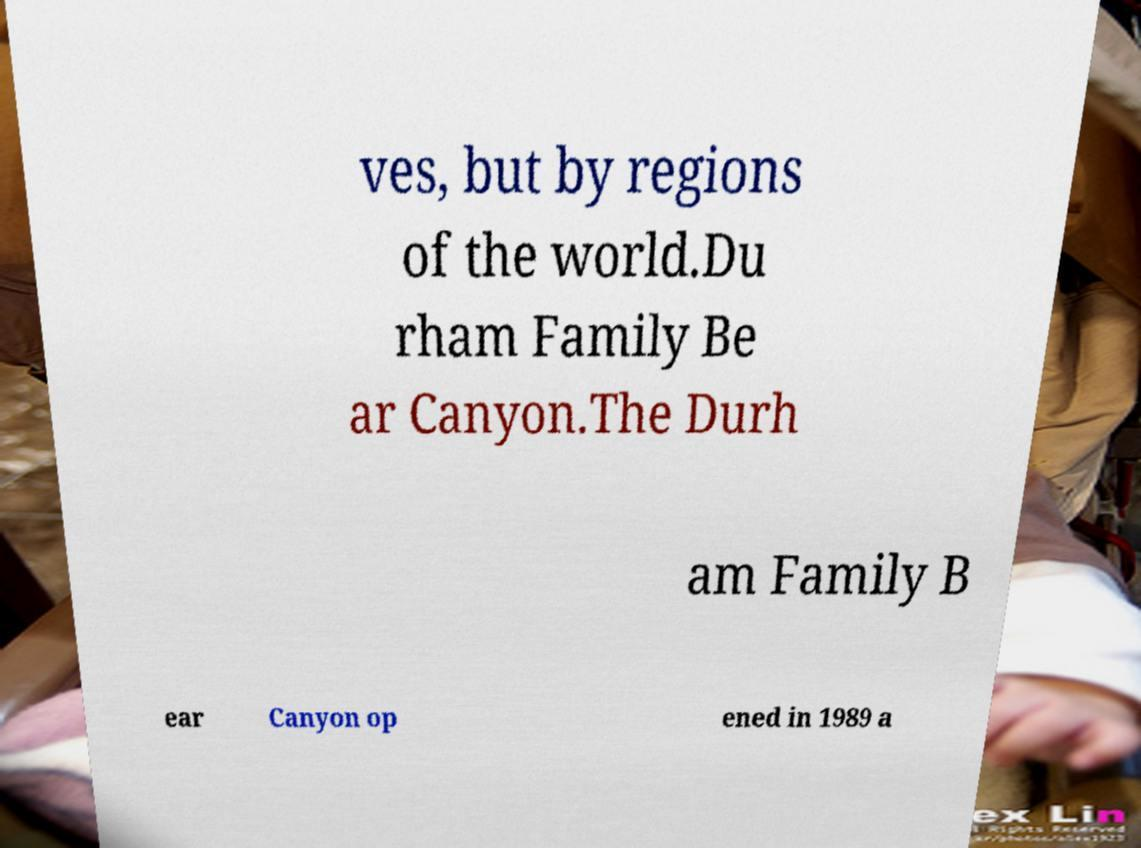Can you read and provide the text displayed in the image?This photo seems to have some interesting text. Can you extract and type it out for me? ves, but by regions of the world.Du rham Family Be ar Canyon.The Durh am Family B ear Canyon op ened in 1989 a 